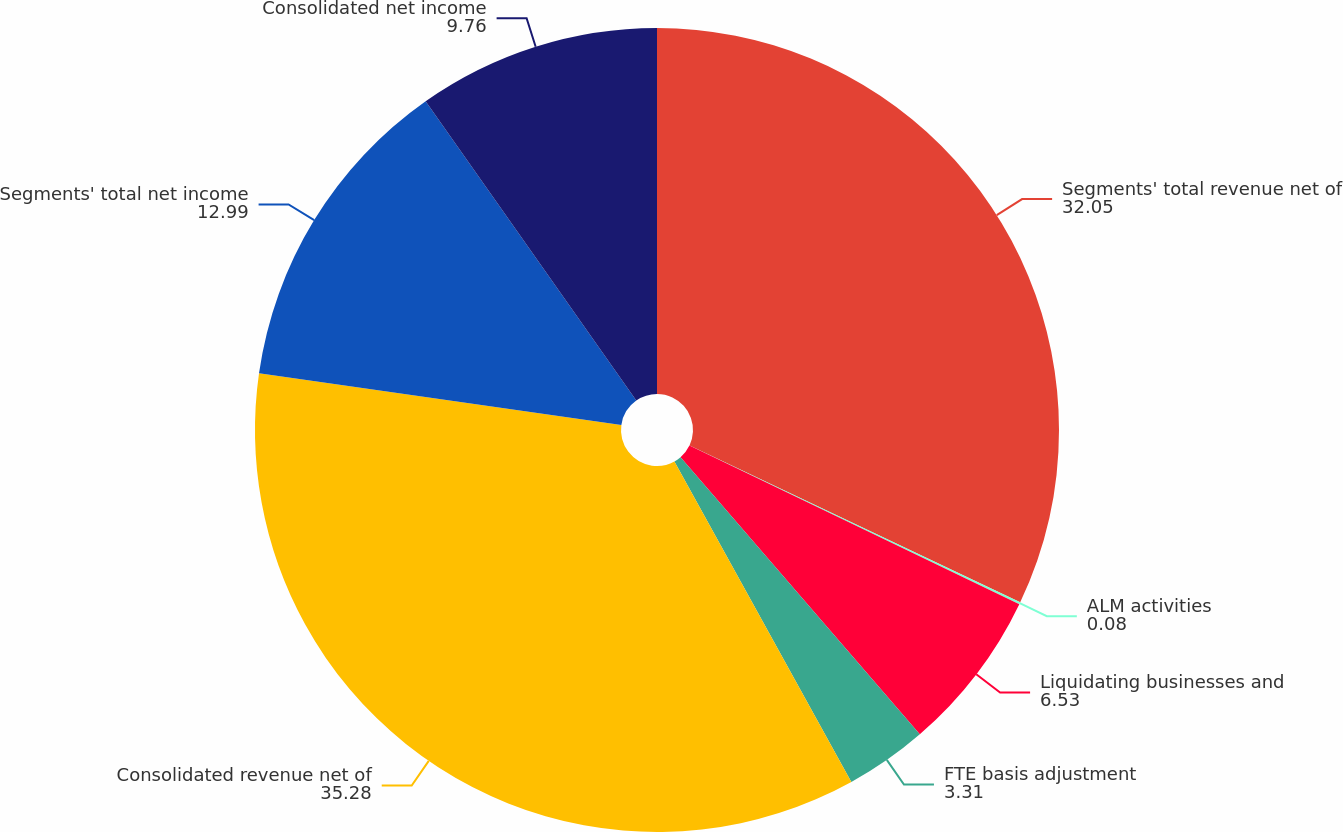Convert chart. <chart><loc_0><loc_0><loc_500><loc_500><pie_chart><fcel>Segments' total revenue net of<fcel>ALM activities<fcel>Liquidating businesses and<fcel>FTE basis adjustment<fcel>Consolidated revenue net of<fcel>Segments' total net income<fcel>Consolidated net income<nl><fcel>32.05%<fcel>0.08%<fcel>6.53%<fcel>3.31%<fcel>35.28%<fcel>12.99%<fcel>9.76%<nl></chart> 